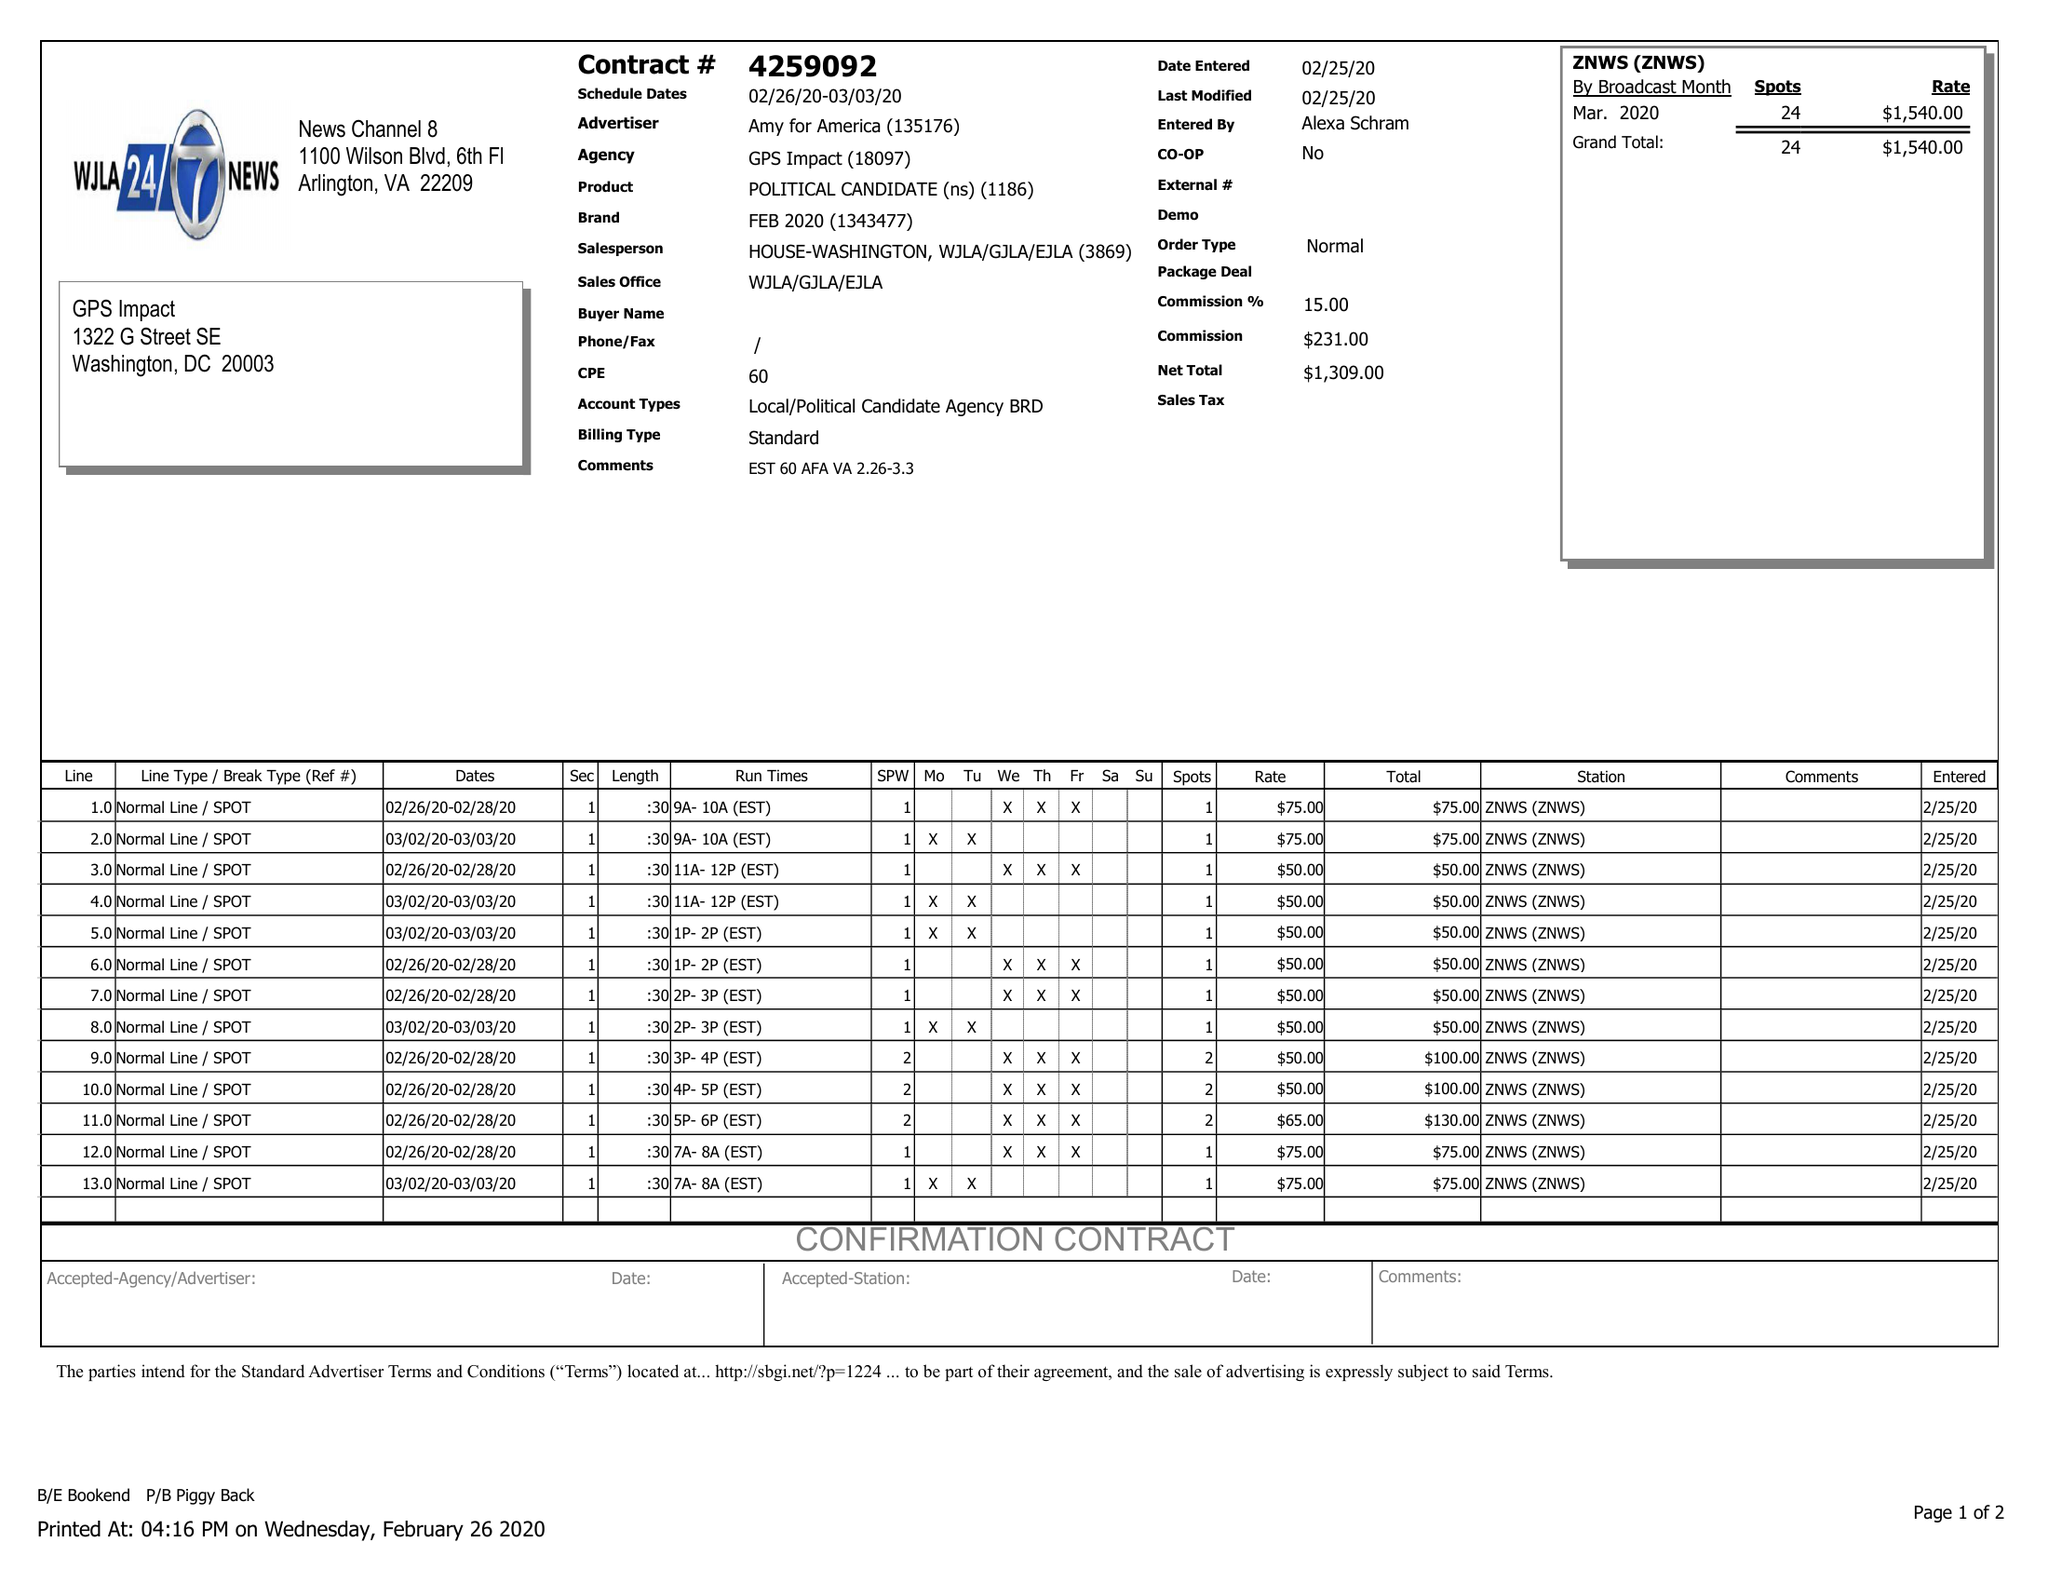What is the value for the flight_to?
Answer the question using a single word or phrase. 03/03/20 